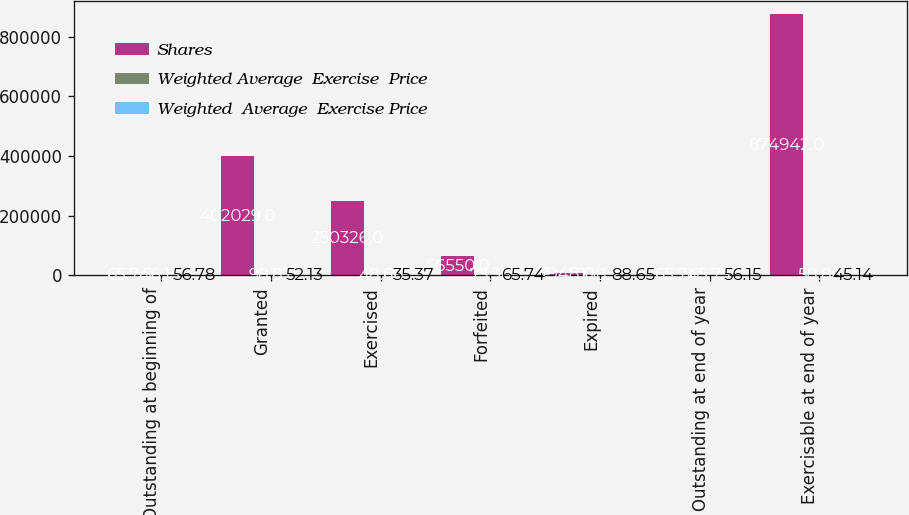Convert chart to OTSL. <chart><loc_0><loc_0><loc_500><loc_500><stacked_bar_chart><ecel><fcel>Outstanding at beginning of<fcel>Granted<fcel>Exercised<fcel>Forfeited<fcel>Expired<fcel>Outstanding at end of year<fcel>Exercisable at end of year<nl><fcel>Shares<fcel>65.74<fcel>402029<fcel>250326<fcel>66550<fcel>7948<fcel>65.74<fcel>874942<nl><fcel>Weighted Average  Exercise  Price<fcel>56.15<fcel>98.87<fcel>48.66<fcel>75.38<fcel>108.2<fcel>65.73<fcel>50.86<nl><fcel>Weighted  Average  Exercise Price<fcel>56.78<fcel>52.13<fcel>35.37<fcel>65.74<fcel>88.65<fcel>56.15<fcel>45.14<nl></chart> 